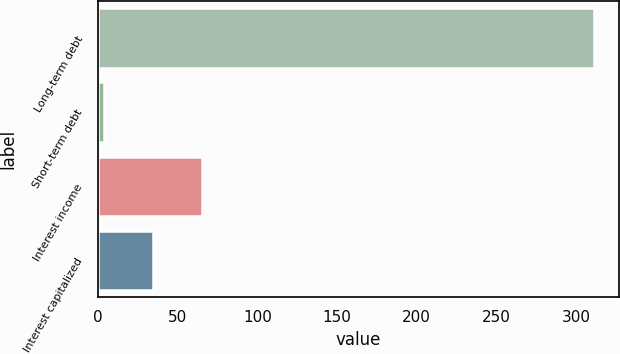Convert chart. <chart><loc_0><loc_0><loc_500><loc_500><bar_chart><fcel>Long-term debt<fcel>Short-term debt<fcel>Interest income<fcel>Interest capitalized<nl><fcel>311.5<fcel>3.8<fcel>65.34<fcel>34.57<nl></chart> 